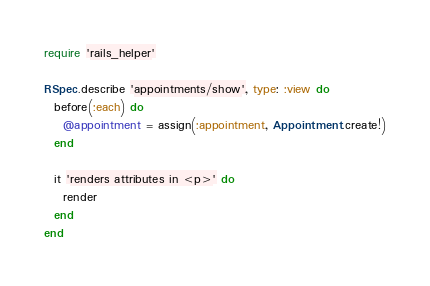Convert code to text. <code><loc_0><loc_0><loc_500><loc_500><_Ruby_>require 'rails_helper'

RSpec.describe 'appointments/show', type: :view do
  before(:each) do
    @appointment = assign(:appointment, Appointment.create!)
  end

  it 'renders attributes in <p>' do
    render
  end
end
</code> 